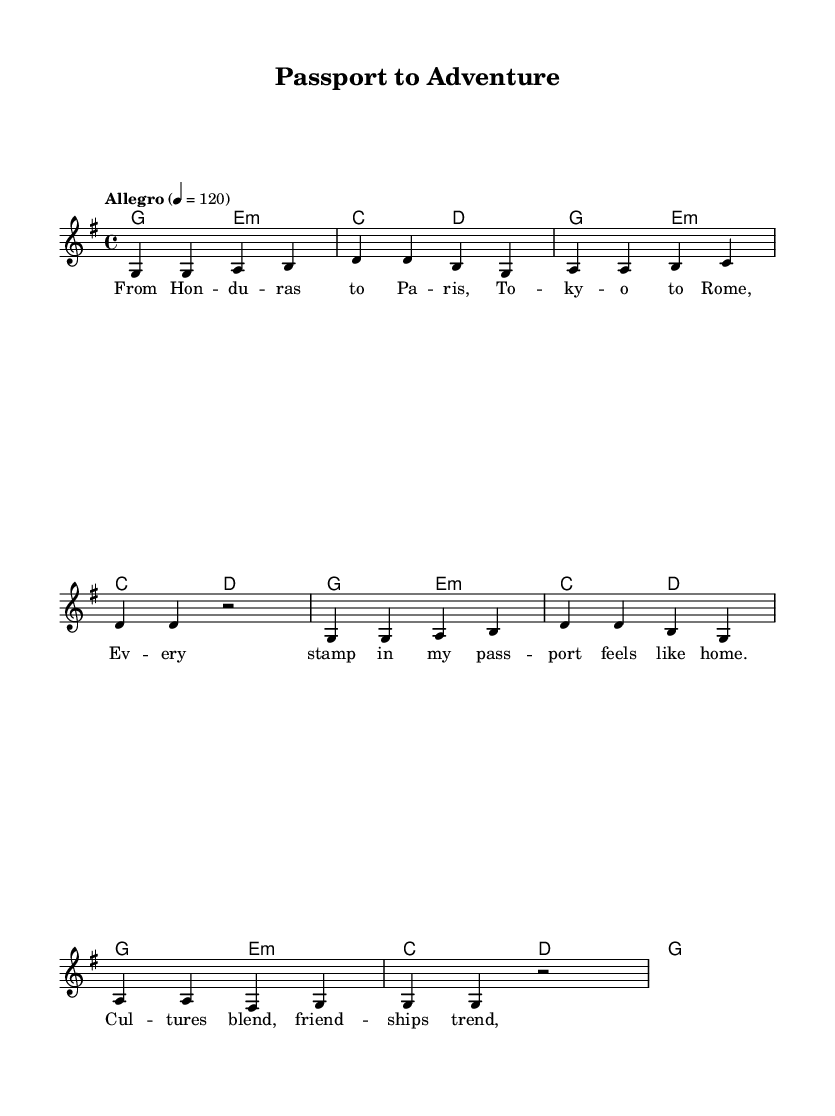What is the key signature of this music? The key signature is G major, which has one sharp (F#). This is indicated at the beginning of the staff.
Answer: G major What is the time signature of the piece? The time signature is 4/4, which means there are four beats in a measure and a quarter note receives one beat. This is also shown at the beginning of the staff.
Answer: 4/4 What is the tempo marking of the piece? The tempo marking is "Allegro" with a metronome marking of 120 beats per minute. This indicates that the piece should be played at a fast and lively pace.
Answer: Allegro How many measures are in the melody? The melody section consists of eight measures in total, as indicated by the grouping of notes and rests within the staff.
Answer: 8 What is the primary theme expressed in the lyrics? The primary theme is about travel and cultural experiences, reflecting joy and connections made through various international journeys. This can be derived from the lyrics that mention different cities and connections.
Answer: Travel What type of chords are used in the harmony section? The harmony section uses a combination of major and minor chords, which contribute to the upbeat and lively feel typical of pop music. The presence of E minor chords alongside major chords creates a dynamic contrast.
Answer: Major and minor What is the overall mood of the song, based on the tempo and lyrics? The overall mood of the song is upbeat and cheerful, influenced by both the lively tempo and the positive, adventurous lyrics. This matches the traits typically found in pop music, designed to evoke feelings of joy and fun.
Answer: Upbeat 